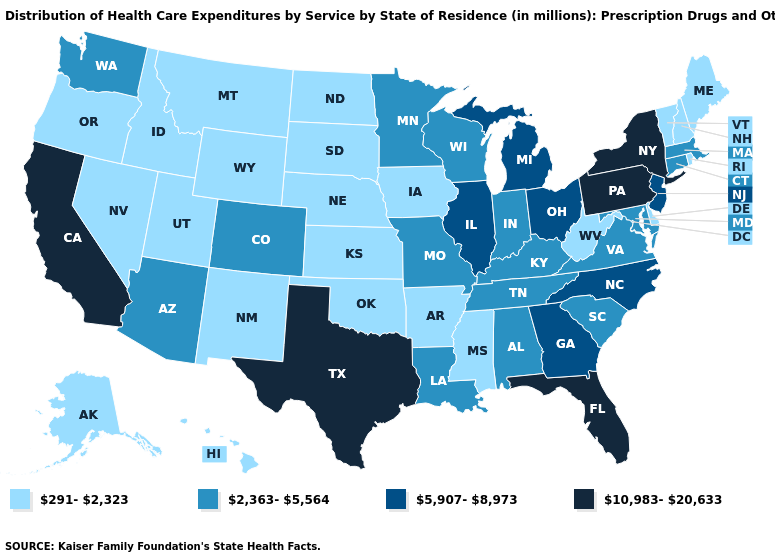Among the states that border Wisconsin , does Iowa have the highest value?
Keep it brief. No. Does Connecticut have the lowest value in the Northeast?
Be succinct. No. Name the states that have a value in the range 5,907-8,973?
Write a very short answer. Georgia, Illinois, Michigan, New Jersey, North Carolina, Ohio. What is the value of Florida?
Keep it brief. 10,983-20,633. What is the lowest value in the South?
Short answer required. 291-2,323. Name the states that have a value in the range 291-2,323?
Concise answer only. Alaska, Arkansas, Delaware, Hawaii, Idaho, Iowa, Kansas, Maine, Mississippi, Montana, Nebraska, Nevada, New Hampshire, New Mexico, North Dakota, Oklahoma, Oregon, Rhode Island, South Dakota, Utah, Vermont, West Virginia, Wyoming. What is the value of Kansas?
Quick response, please. 291-2,323. Does Oklahoma have the highest value in the South?
Write a very short answer. No. Among the states that border Oklahoma , which have the highest value?
Give a very brief answer. Texas. Which states have the lowest value in the USA?
Answer briefly. Alaska, Arkansas, Delaware, Hawaii, Idaho, Iowa, Kansas, Maine, Mississippi, Montana, Nebraska, Nevada, New Hampshire, New Mexico, North Dakota, Oklahoma, Oregon, Rhode Island, South Dakota, Utah, Vermont, West Virginia, Wyoming. Among the states that border Massachusetts , does New York have the highest value?
Be succinct. Yes. What is the value of Alaska?
Concise answer only. 291-2,323. What is the highest value in the Northeast ?
Keep it brief. 10,983-20,633. Name the states that have a value in the range 2,363-5,564?
Keep it brief. Alabama, Arizona, Colorado, Connecticut, Indiana, Kentucky, Louisiana, Maryland, Massachusetts, Minnesota, Missouri, South Carolina, Tennessee, Virginia, Washington, Wisconsin. What is the value of Nevada?
Short answer required. 291-2,323. 